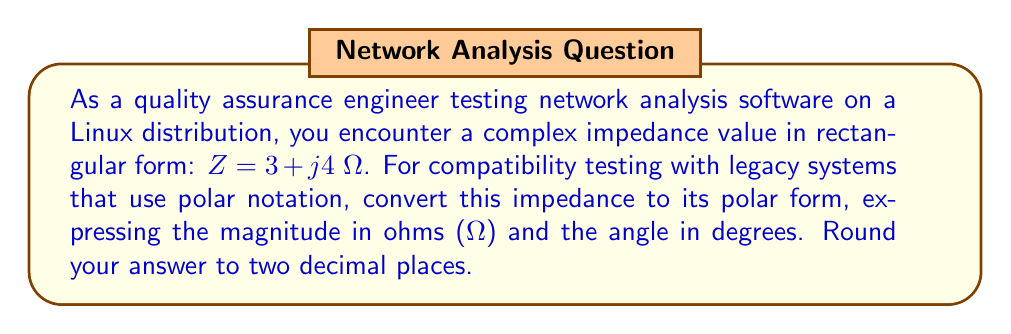Can you solve this math problem? To convert a complex number from rectangular form $(a + jb)$ to polar form $(r \angle \theta)$, we use the following formulas:

1. Magnitude (r): $r = \sqrt{a^2 + b^2}$
2. Angle (θ): $\theta = \tan^{-1}(\frac{b}{a})$

For the given impedance $Z = 3 + j4$ Ω:

1. Calculate the magnitude:
   $$r = \sqrt{3^2 + 4^2} = \sqrt{9 + 16} = \sqrt{25} = 5\text{ Ω}$$

2. Calculate the angle:
   $$\theta = \tan^{-1}(\frac{4}{3}) \approx 53.13^\circ$$

   Note: We use the $\tan^{-1}$ function here because both the real and imaginary parts are positive (Quadrant I).

Therefore, the polar form of the impedance is $5 \angle 53.13^\circ$ Ω.

Rounding to two decimal places: $5.00 \angle 53.13^\circ$ Ω
Answer: $5.00 \angle 53.13^\circ$ Ω 